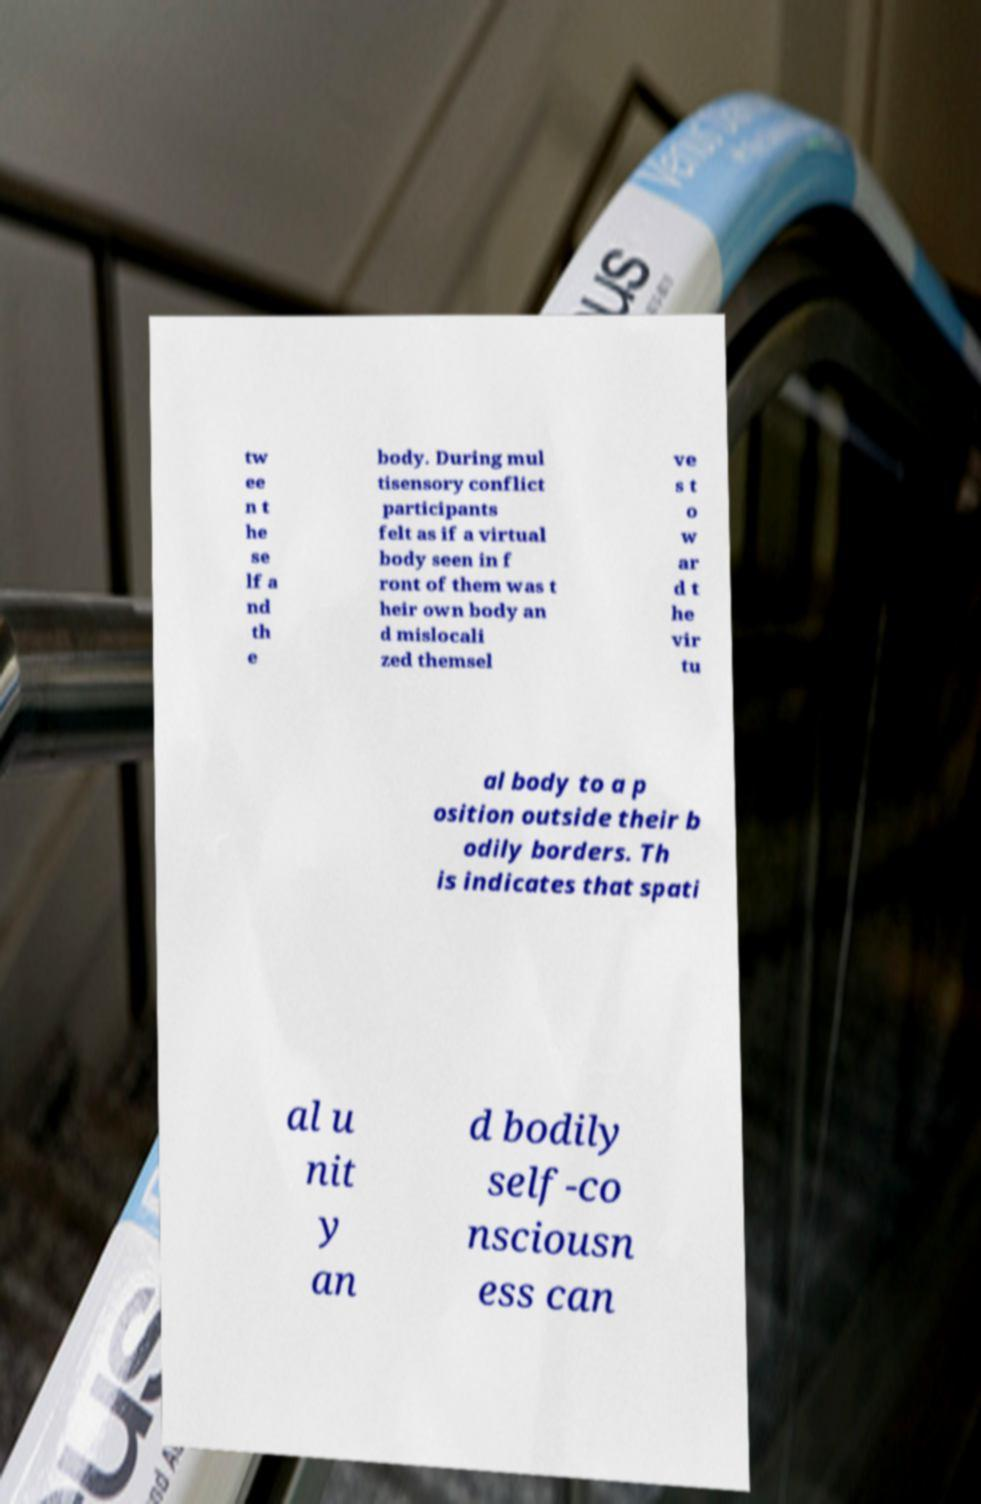Can you read and provide the text displayed in the image?This photo seems to have some interesting text. Can you extract and type it out for me? tw ee n t he se lf a nd th e body. During mul tisensory conflict participants felt as if a virtual body seen in f ront of them was t heir own body an d mislocali zed themsel ve s t o w ar d t he vir tu al body to a p osition outside their b odily borders. Th is indicates that spati al u nit y an d bodily self-co nsciousn ess can 